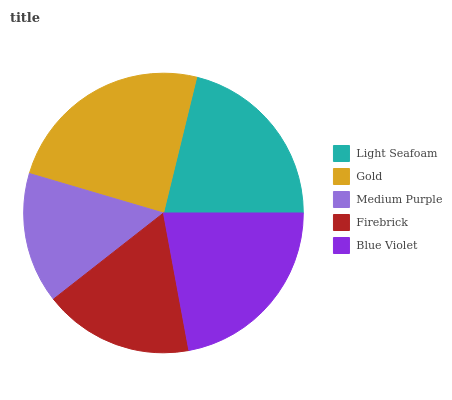Is Medium Purple the minimum?
Answer yes or no. Yes. Is Gold the maximum?
Answer yes or no. Yes. Is Gold the minimum?
Answer yes or no. No. Is Medium Purple the maximum?
Answer yes or no. No. Is Gold greater than Medium Purple?
Answer yes or no. Yes. Is Medium Purple less than Gold?
Answer yes or no. Yes. Is Medium Purple greater than Gold?
Answer yes or no. No. Is Gold less than Medium Purple?
Answer yes or no. No. Is Light Seafoam the high median?
Answer yes or no. Yes. Is Light Seafoam the low median?
Answer yes or no. Yes. Is Blue Violet the high median?
Answer yes or no. No. Is Gold the low median?
Answer yes or no. No. 